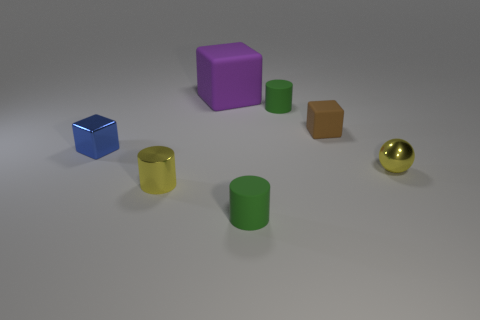Add 3 yellow metallic cylinders. How many objects exist? 10 Subtract all small green cylinders. How many cylinders are left? 1 Subtract all green cylinders. How many cylinders are left? 1 Subtract all spheres. How many objects are left? 6 Subtract 1 balls. How many balls are left? 0 Subtract all gray cubes. Subtract all brown balls. How many cubes are left? 3 Subtract all gray cylinders. How many red spheres are left? 0 Subtract all rubber cylinders. Subtract all tiny matte blocks. How many objects are left? 4 Add 2 big purple blocks. How many big purple blocks are left? 3 Add 2 purple things. How many purple things exist? 3 